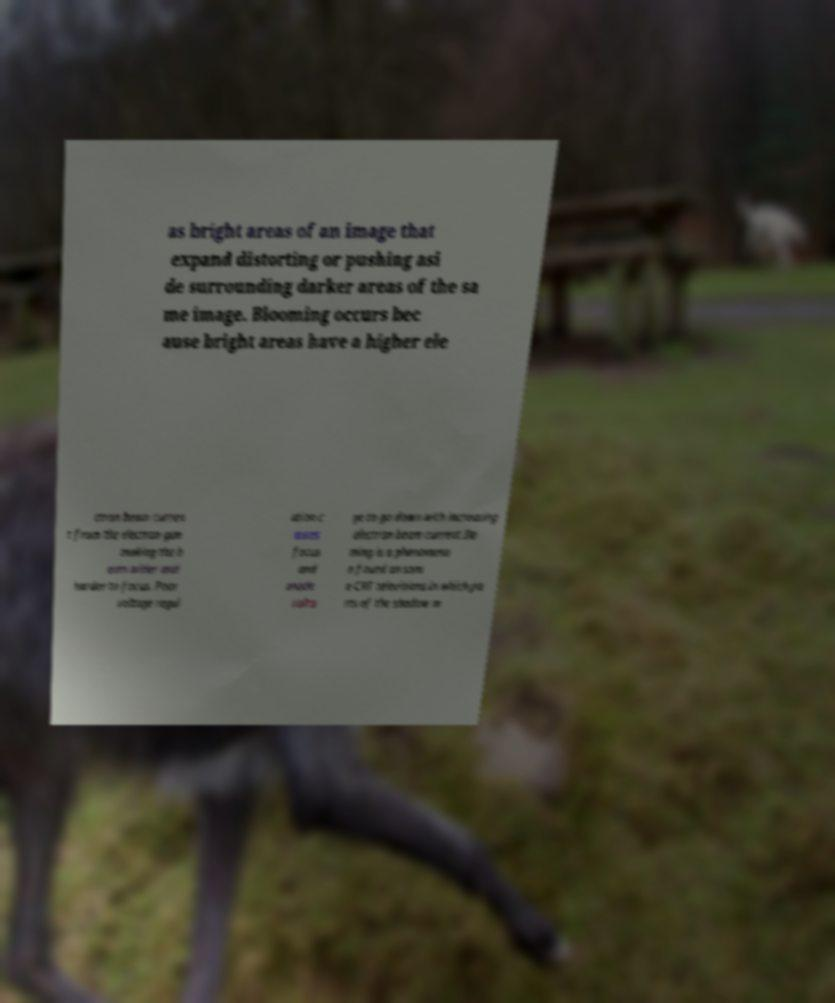Can you read and provide the text displayed in the image?This photo seems to have some interesting text. Can you extract and type it out for me? as bright areas of an image that expand distorting or pushing asi de surrounding darker areas of the sa me image. Blooming occurs bec ause bright areas have a higher ele ctron beam curren t from the electron gun making the b eam wider and harder to focus. Poor voltage regul ation c auses focus and anode volta ge to go down with increasing electron beam current.Do ming is a phenomeno n found on som e CRT televisions in which pa rts of the shadow m 